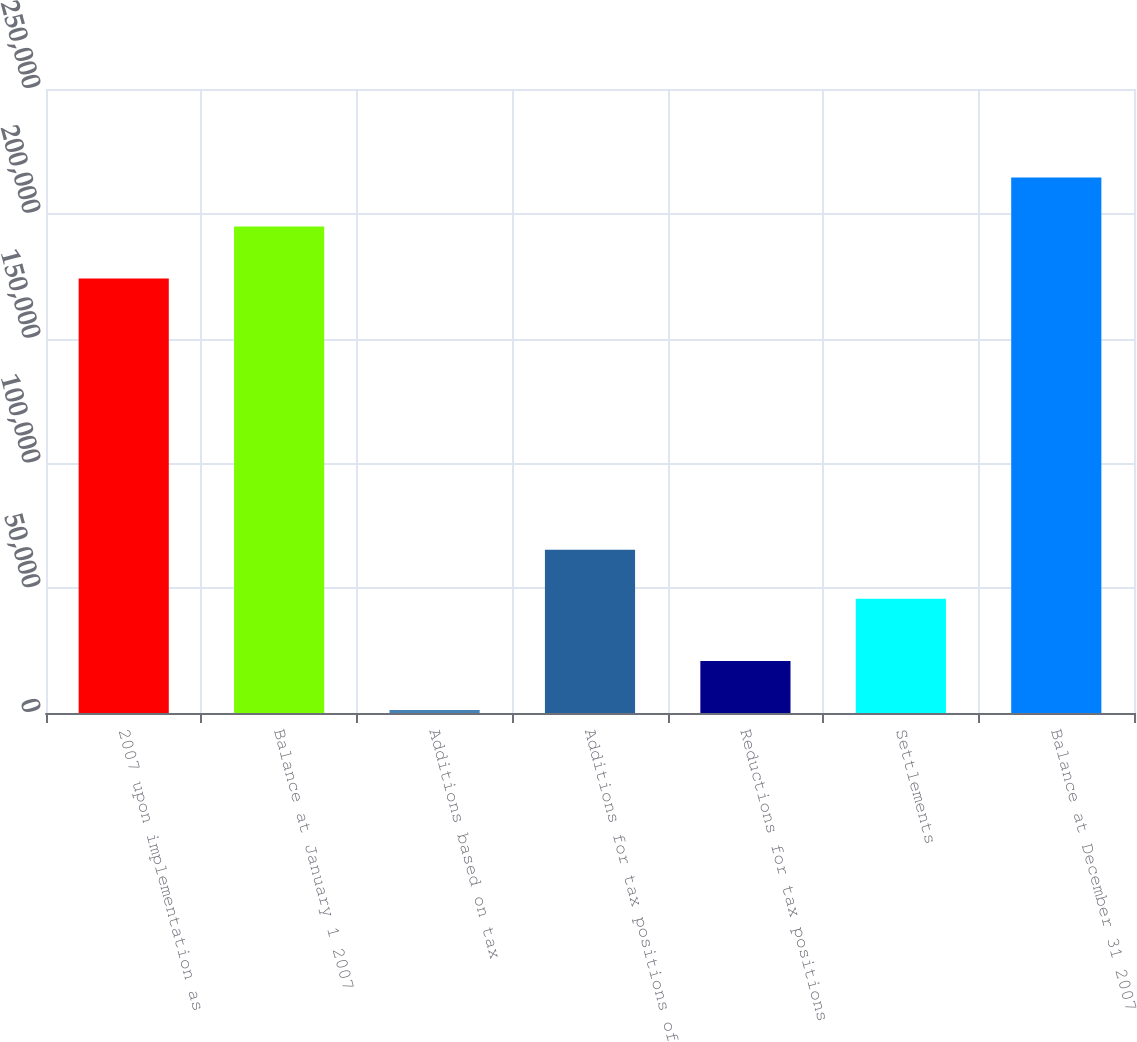Convert chart. <chart><loc_0><loc_0><loc_500><loc_500><bar_chart><fcel>2007 upon implementation as<fcel>Balance at January 1 2007<fcel>Additions based on tax<fcel>Additions for tax positions of<fcel>Reductions for tax positions<fcel>Settlements<fcel>Balance at December 31 2007<nl><fcel>174093<fcel>194881<fcel>1184<fcel>65430.3<fcel>20796.3<fcel>45818<fcel>214493<nl></chart> 